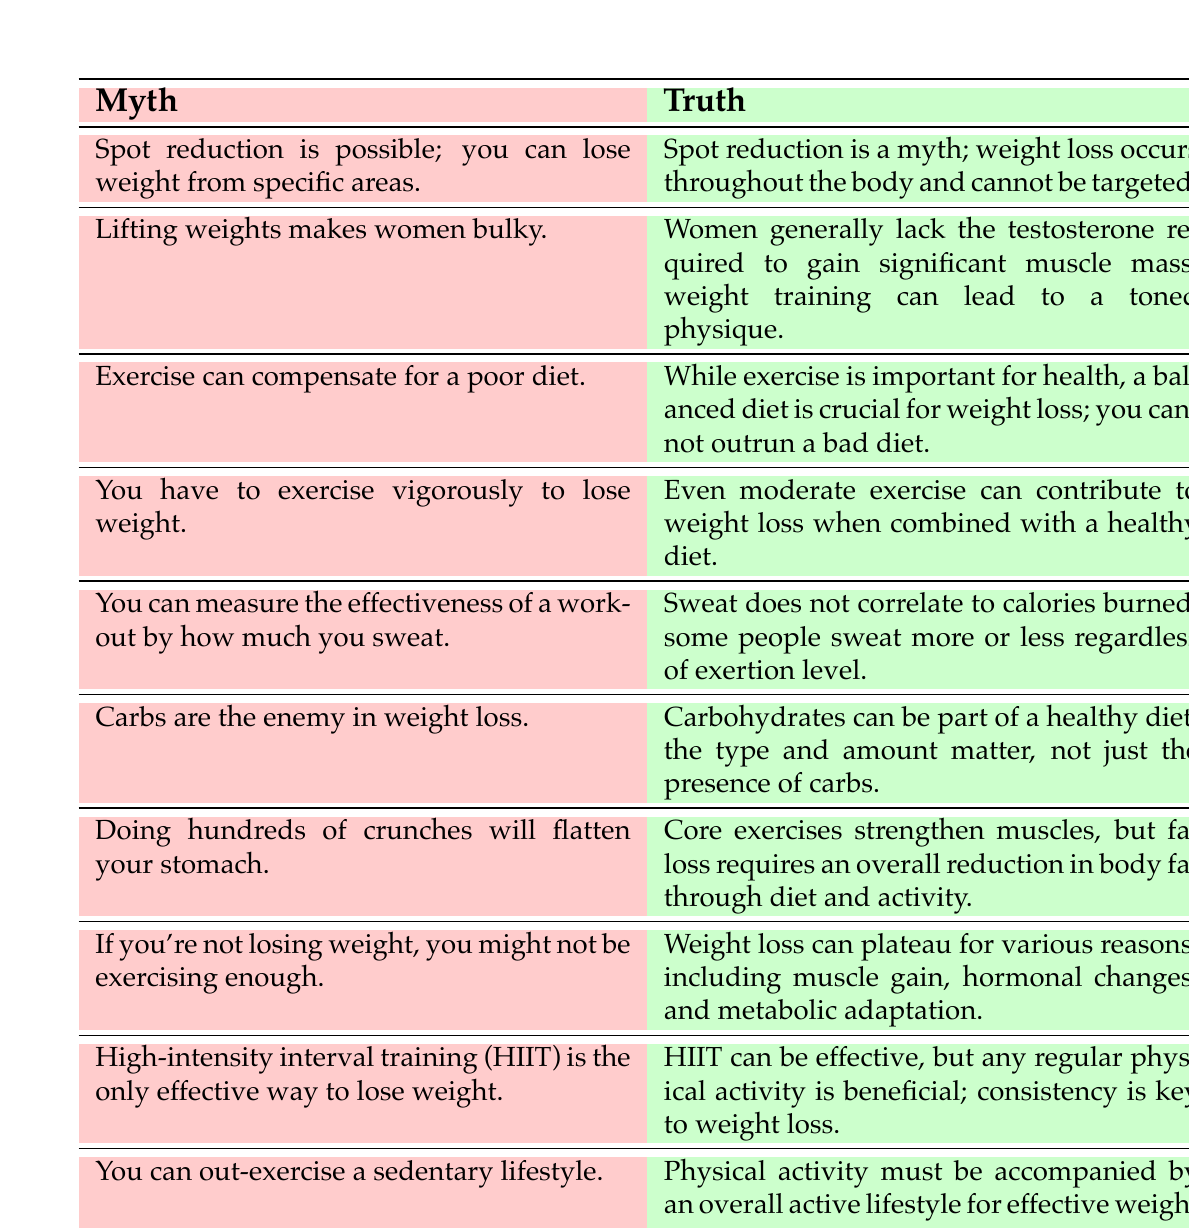What myth claims that you can lose weight from specific areas? The table clearly states that the myth is "Spot reduction is possible; you can lose weight from specific areas."
Answer: Spot reduction is possible; you can lose weight from specific areas What is the truth regarding women lifting weights? The truth according to the table is, "Women generally lack the testosterone required to gain significant muscle mass; weight training can lead to a toned physique."
Answer: Women generally lack testosterone to gain significant muscle mass Is the statement "Exercise can compensate for a poor diet" true or false? The table presents the truth that highlights the importance of a balanced diet, indicating that this statement is false: "While exercise is important for health, a balanced diet is crucial for weight loss; you cannot outrun a bad diet."
Answer: False How many myths mention the effectiveness of high-intensity interval training (HIIT)? Scanning the table shows one specific myth regarding HIIT: "High-intensity interval training (HIIT) is the only effective way to lose weight." Thus, there is only one myth about HIIT.
Answer: One If you believe that you have to exercise vigorously to lose weight, what is the truth? According to the table, the truth states: "Even moderate exercise can contribute to weight loss when combined with a healthy diet," contradicting the myth.
Answer: Even moderate exercise can contribute to weight loss What are the two factors that contribute to weight loss, as mentioned in the table? The relevant rows indicate that a healthy diet and exercise contribute to weight loss: "Even moderate exercise can contribute to weight loss when combined with a healthy diet." Thus, both factors are diet and exercise.
Answer: Diet and exercise What correlations can be drawn from the myth about measuring workout effectiveness through sweat? The table specifies that "Sweat does not correlate to calories burned; some people sweat more or less regardless of exertion level," indicating there is no correlation between sweat and workout effectiveness.
Answer: No correlation In terms of total myths presented in the table, how many address misconceptions about diet? By reviewing the table, there are three myths related to diet: "Carbs are the enemy in weight loss," "Exercise can compensate for a poor diet," and the myth about crunches (implying fat loss). Therefore, there are three diet-related myths.
Answer: Three 